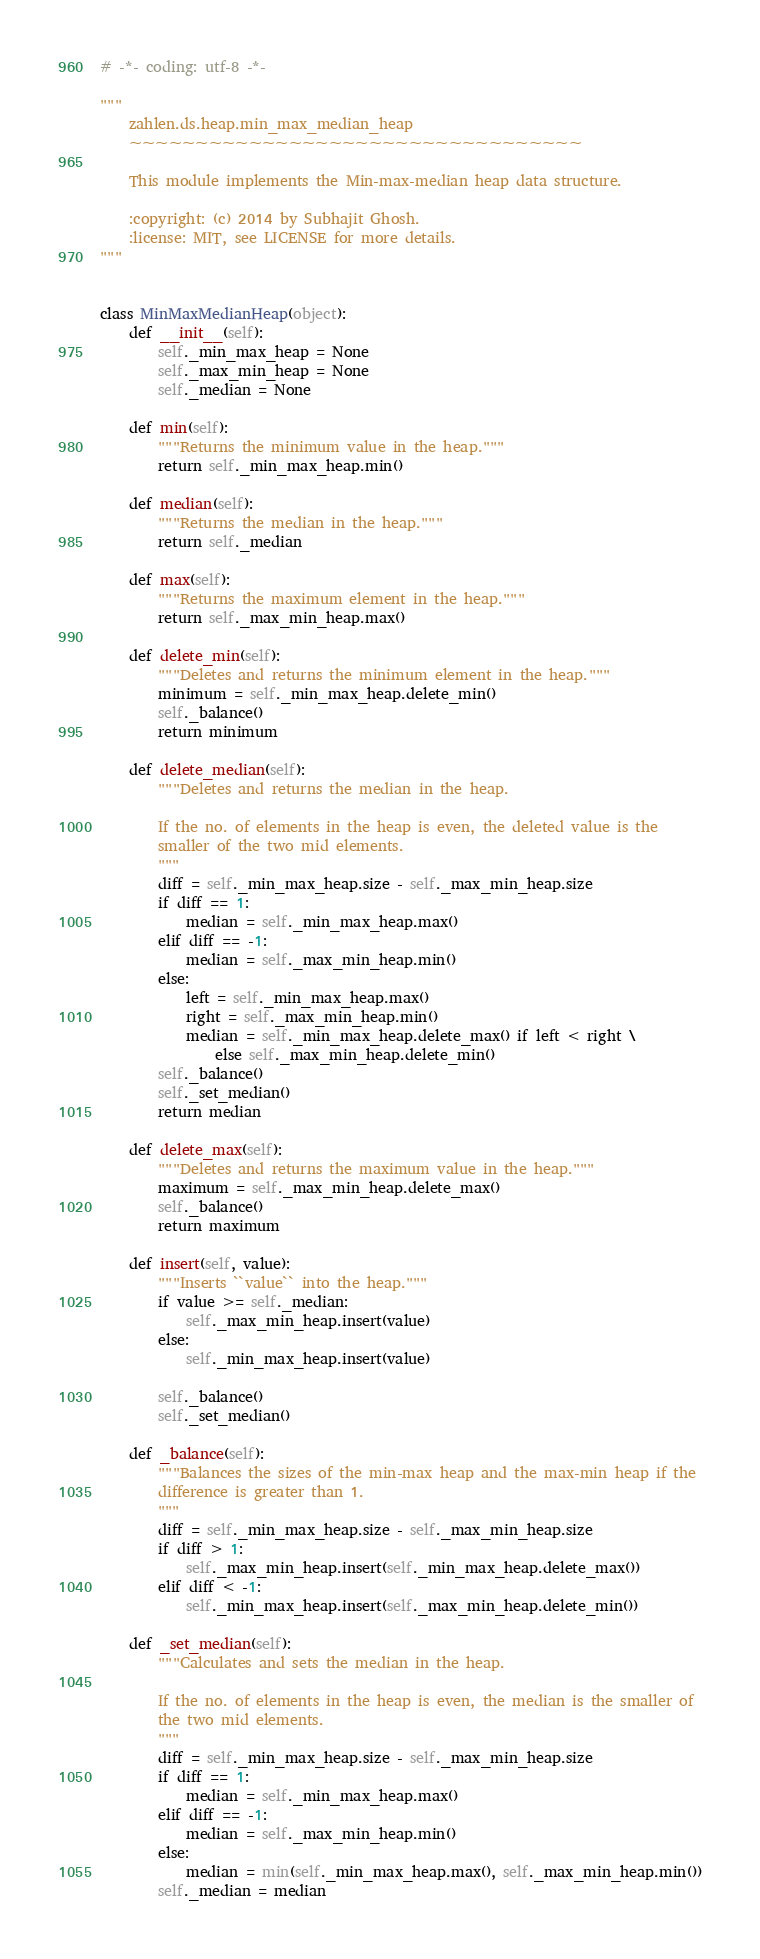<code> <loc_0><loc_0><loc_500><loc_500><_Python_># -*- coding: utf-8 -*-

"""
    zahlen.ds.heap.min_max_median_heap
    ~~~~~~~~~~~~~~~~~~~~~~~~~~~~~~~~~~

    This module implements the Min-max-median heap data structure.

    :copyright: (c) 2014 by Subhajit Ghosh.
    :license: MIT, see LICENSE for more details.
"""


class MinMaxMedianHeap(object):
    def __init__(self):
        self._min_max_heap = None
        self._max_min_heap = None
        self._median = None

    def min(self):
        """Returns the minimum value in the heap."""
        return self._min_max_heap.min()

    def median(self):
        """Returns the median in the heap."""
        return self._median

    def max(self):
        """Returns the maximum element in the heap."""
        return self._max_min_heap.max()

    def delete_min(self):
        """Deletes and returns the minimum element in the heap."""
        minimum = self._min_max_heap.delete_min()
        self._balance()
        return minimum

    def delete_median(self):
        """Deletes and returns the median in the heap.

        If the no. of elements in the heap is even, the deleted value is the
        smaller of the two mid elements.
        """
        diff = self._min_max_heap.size - self._max_min_heap.size
        if diff == 1:
            median = self._min_max_heap.max()
        elif diff == -1:
            median = self._max_min_heap.min()
        else:
            left = self._min_max_heap.max()
            right = self._max_min_heap.min()
            median = self._min_max_heap.delete_max() if left < right \
                else self._max_min_heap.delete_min()
        self._balance()
        self._set_median()
        return median

    def delete_max(self):
        """Deletes and returns the maximum value in the heap."""
        maximum = self._max_min_heap.delete_max()
        self._balance()
        return maximum

    def insert(self, value):
        """Inserts ``value`` into the heap."""
        if value >= self._median:
            self._max_min_heap.insert(value)
        else:
            self._min_max_heap.insert(value)

        self._balance()
        self._set_median()

    def _balance(self):
        """Balances the sizes of the min-max heap and the max-min heap if the
        difference is greater than 1.
        """
        diff = self._min_max_heap.size - self._max_min_heap.size
        if diff > 1:
            self._max_min_heap.insert(self._min_max_heap.delete_max())
        elif diff < -1:
            self._min_max_heap.insert(self._max_min_heap.delete_min())

    def _set_median(self):
        """Calculates and sets the median in the heap.

        If the no. of elements in the heap is even, the median is the smaller of
        the two mid elements.
        """
        diff = self._min_max_heap.size - self._max_min_heap.size
        if diff == 1:
            median = self._min_max_heap.max()
        elif diff == -1:
            median = self._max_min_heap.min()
        else:
            median = min(self._min_max_heap.max(), self._max_min_heap.min())
        self._median = median</code> 